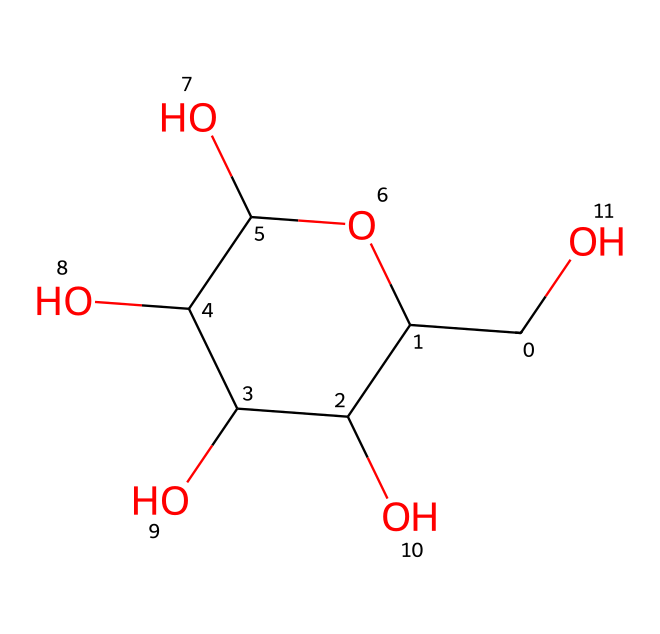What is the name of this chemical? The SMILES representation corresponds to the chemical structure of glucose, which is a common simple sugar.
Answer: glucose How many carbon atoms are in glucose? Analyzing the SMILES, the representation shows 6 carbon atoms present in the structure of glucose.
Answer: 6 What functional groups are present in glucose? The structure contains multiple hydroxyl (-OH) groups, indicating that glucose is an alcohol, which is characteristic for sugars.
Answer: hydroxyl groups What is the total number of oxygen atoms in glucose? By examining the chemical structure encoded in the SMILES, we can identify 6 oxygen atoms in total of glucose.
Answer: 6 Is glucose a saturated or unsaturated compound? Glucose is a saturated compound as it contains only single bonds between its carbon atoms, which means there are no double or triple bonds present.
Answer: saturated What type of isomerism is exhibited by glucose? Glucose exhibits structural isomerism, as it has different structural forms like alpha and beta anomers due to the configuration around the anomeric carbon (C1).
Answer: structural isomerism 